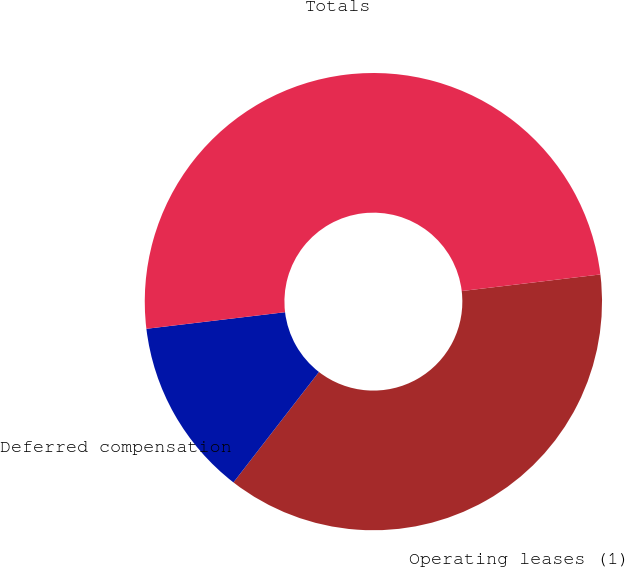<chart> <loc_0><loc_0><loc_500><loc_500><pie_chart><fcel>Operating leases (1)<fcel>Deferred compensation<fcel>Totals<nl><fcel>37.38%<fcel>12.62%<fcel>50.0%<nl></chart> 